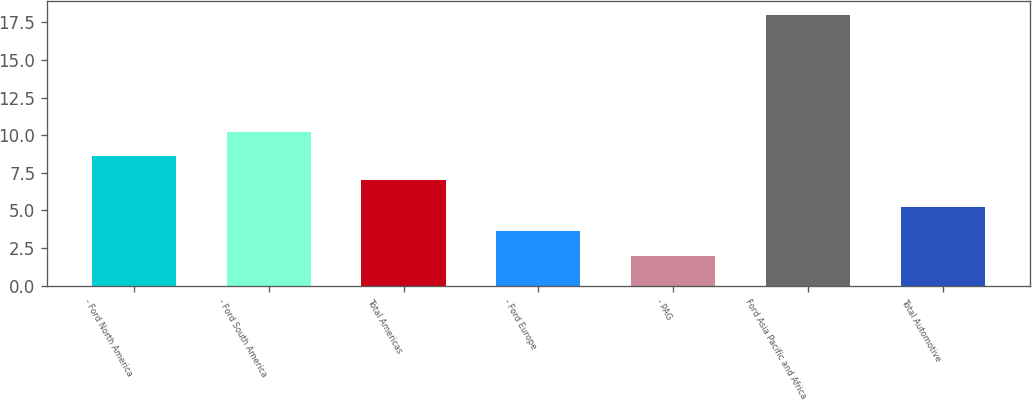Convert chart to OTSL. <chart><loc_0><loc_0><loc_500><loc_500><bar_chart><fcel>- Ford North America<fcel>- Ford South America<fcel>Total Americas<fcel>- Ford Europe<fcel>- PAG<fcel>Ford Asia Pacific and Africa<fcel>Total Automotive<nl><fcel>8.6<fcel>10.2<fcel>7<fcel>3.6<fcel>2<fcel>18<fcel>5.2<nl></chart> 